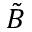<formula> <loc_0><loc_0><loc_500><loc_500>\tilde { B }</formula> 